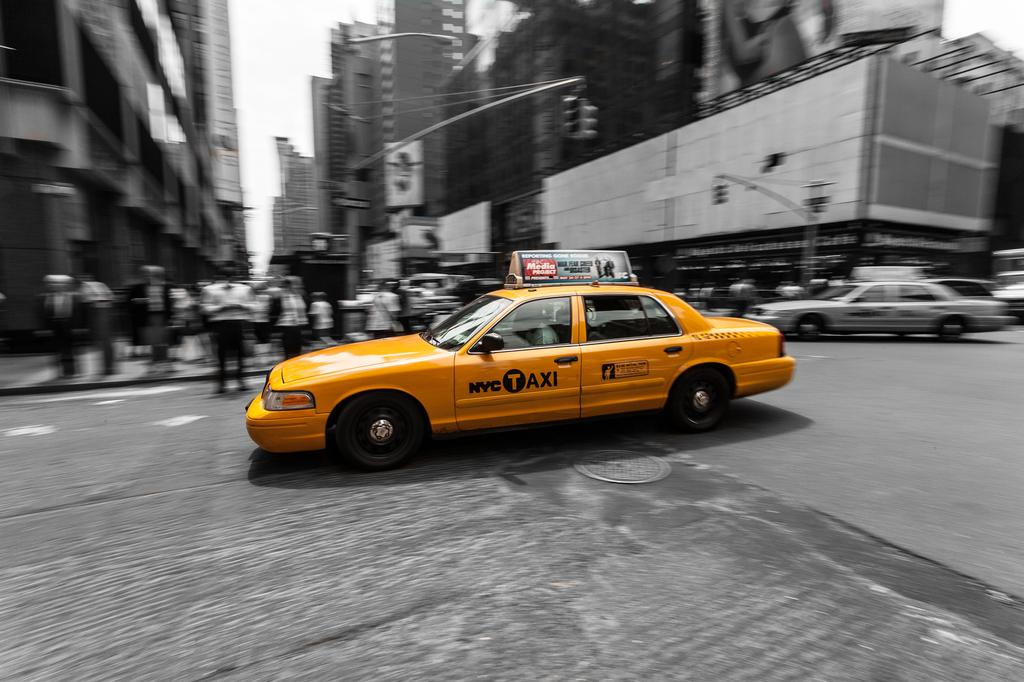<image>
Offer a succinct explanation of the picture presented. a taxi that is in the middle of the street 